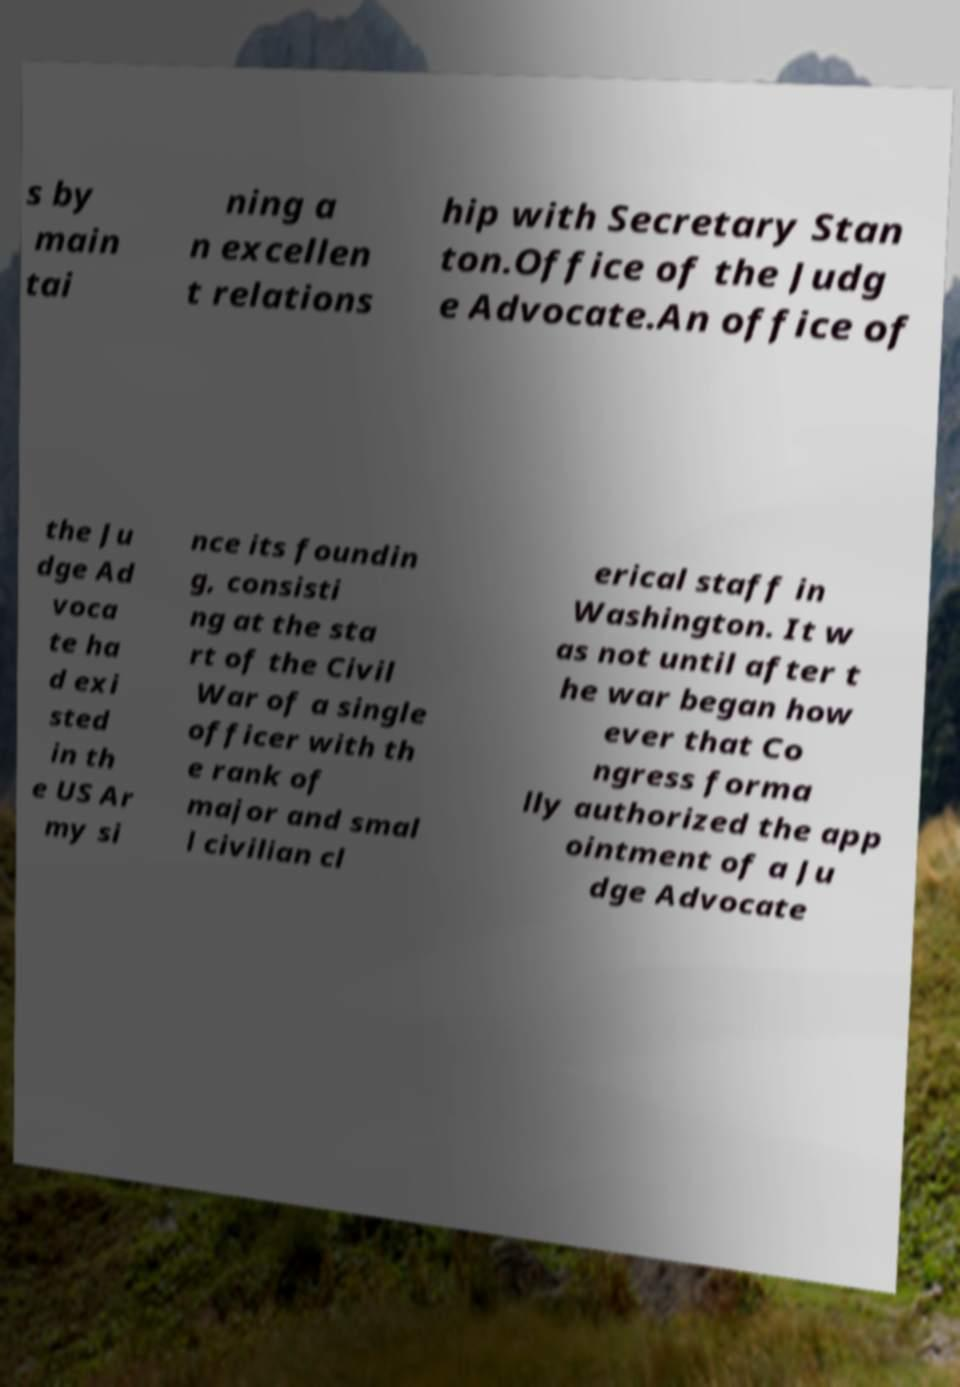I need the written content from this picture converted into text. Can you do that? s by main tai ning a n excellen t relations hip with Secretary Stan ton.Office of the Judg e Advocate.An office of the Ju dge Ad voca te ha d exi sted in th e US Ar my si nce its foundin g, consisti ng at the sta rt of the Civil War of a single officer with th e rank of major and smal l civilian cl erical staff in Washington. It w as not until after t he war began how ever that Co ngress forma lly authorized the app ointment of a Ju dge Advocate 